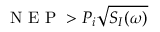<formula> <loc_0><loc_0><loc_500><loc_500>N E P > P _ { i } \sqrt { S _ { I } ( \omega ) }</formula> 